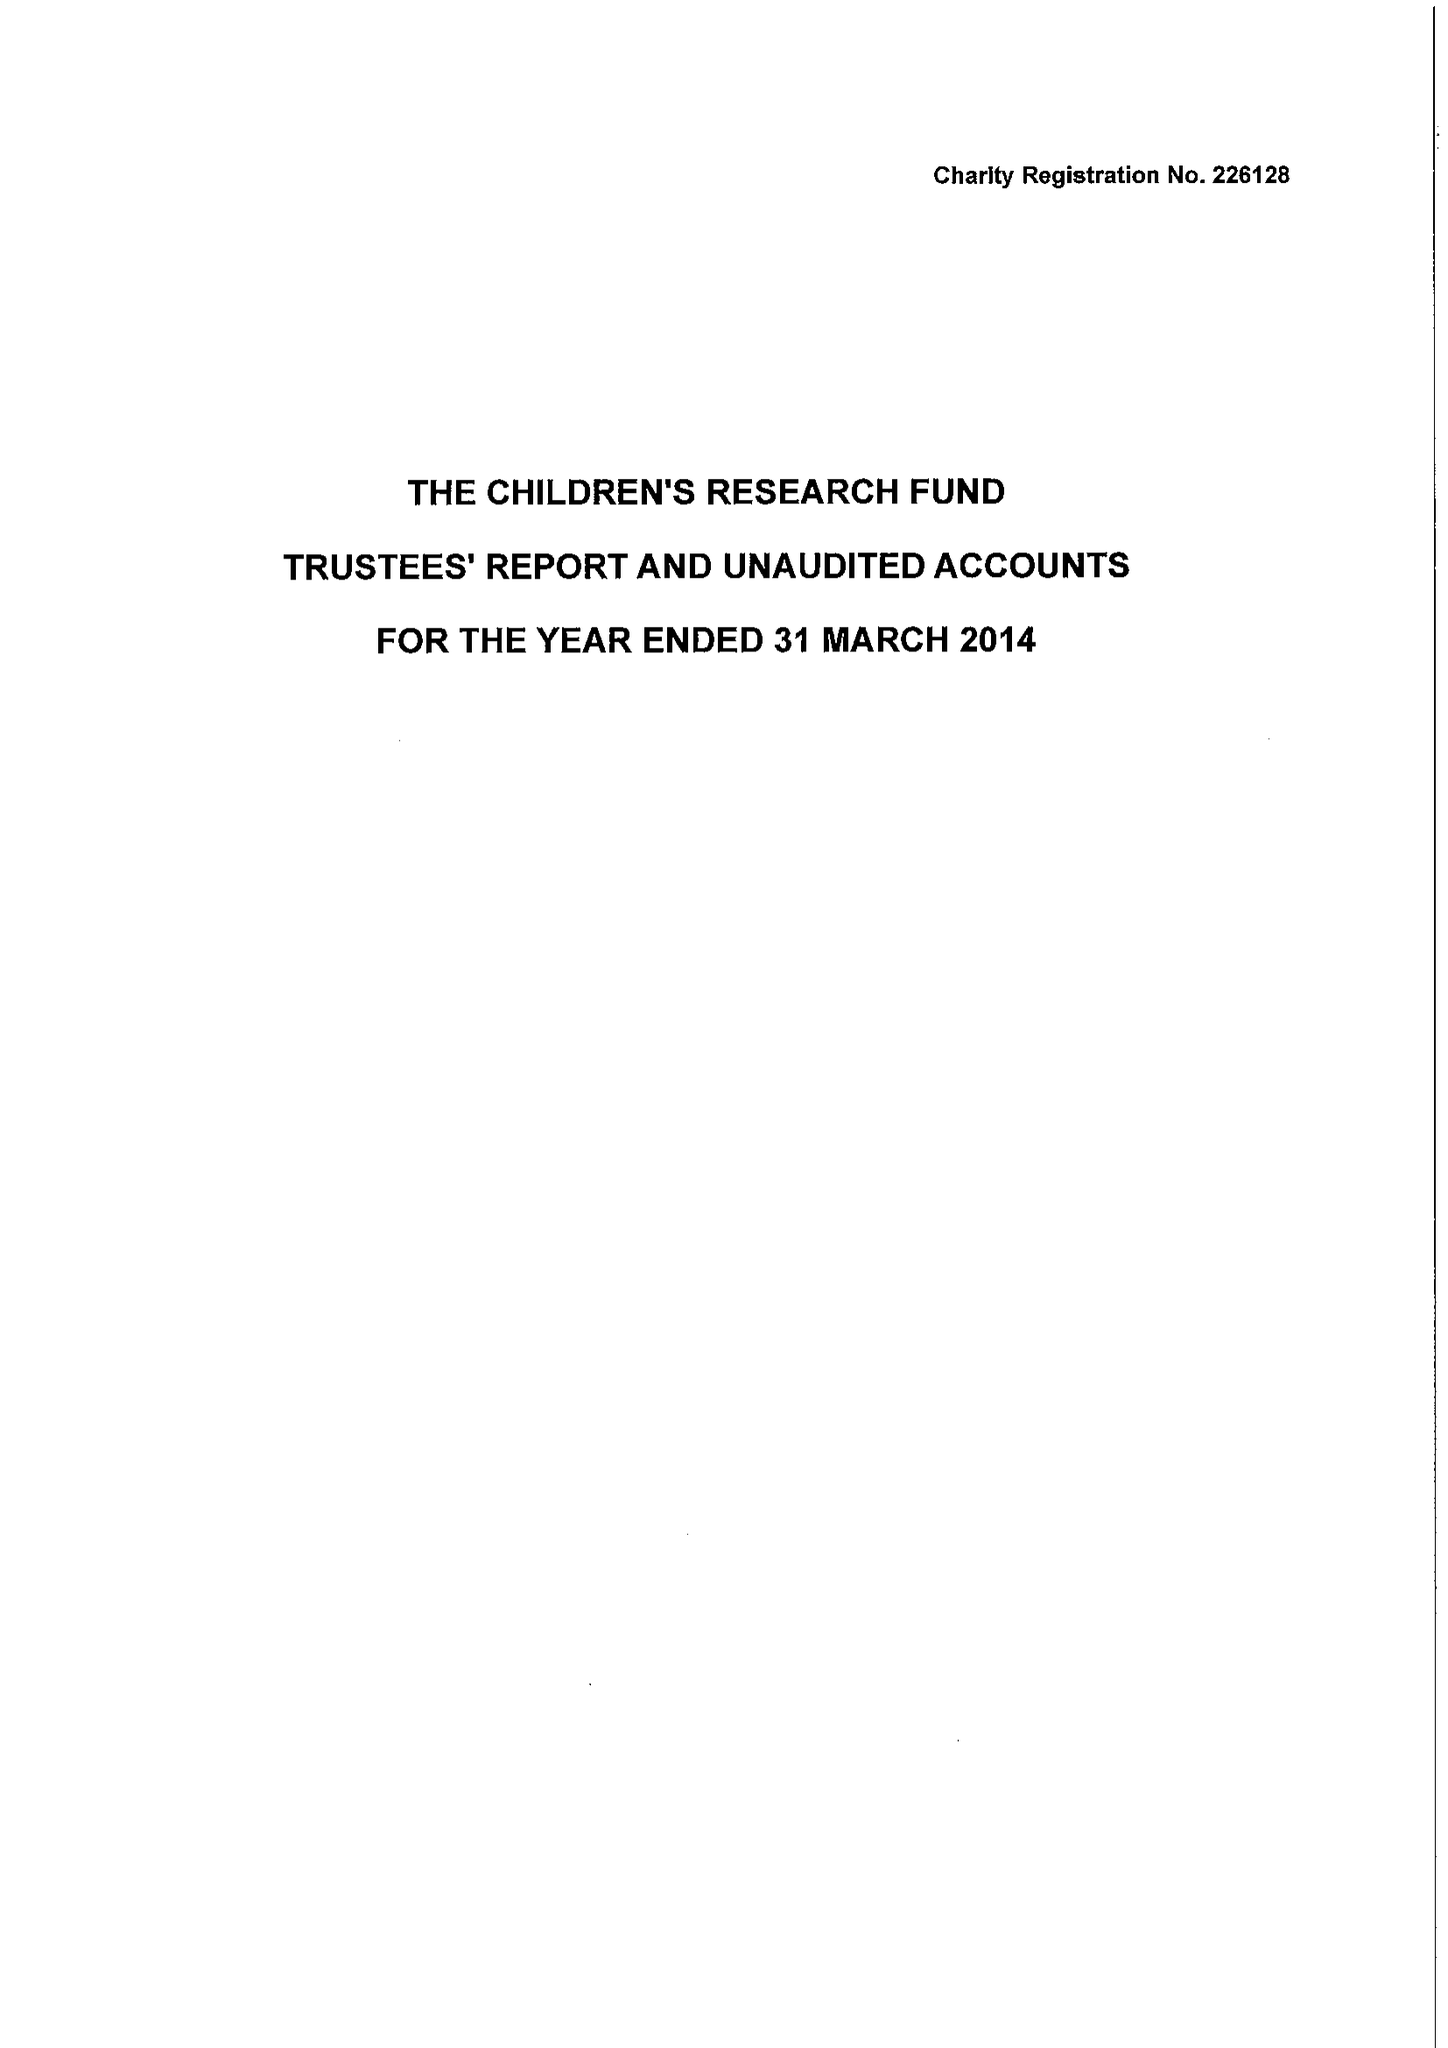What is the value for the spending_annually_in_british_pounds?
Answer the question using a single word or phrase. 9962.00 